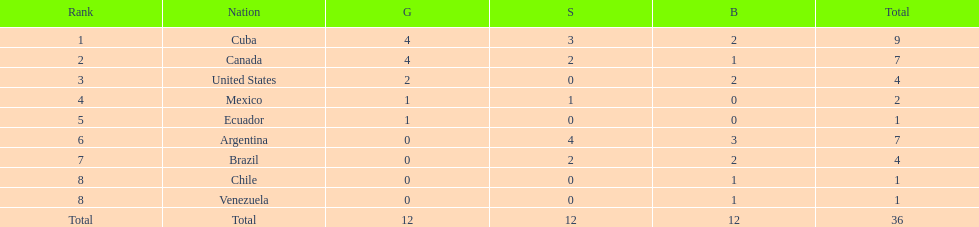Which is the only nation to win a gold medal and nothing else? Ecuador. 